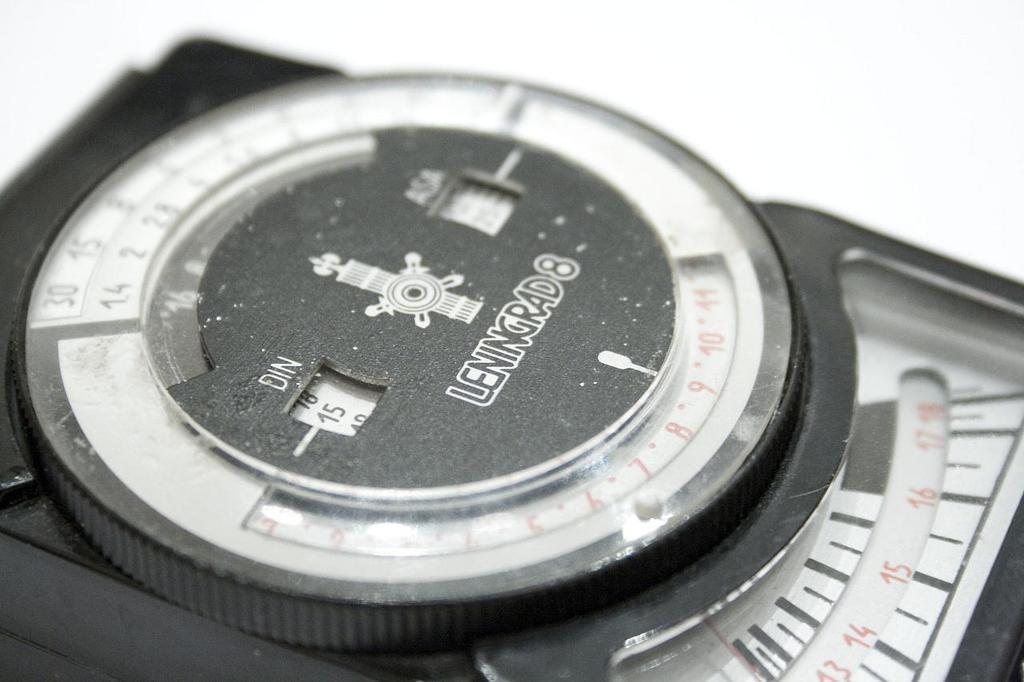<image>
Describe the image concisely. A machine showing the number 15 is sitting on a table. 